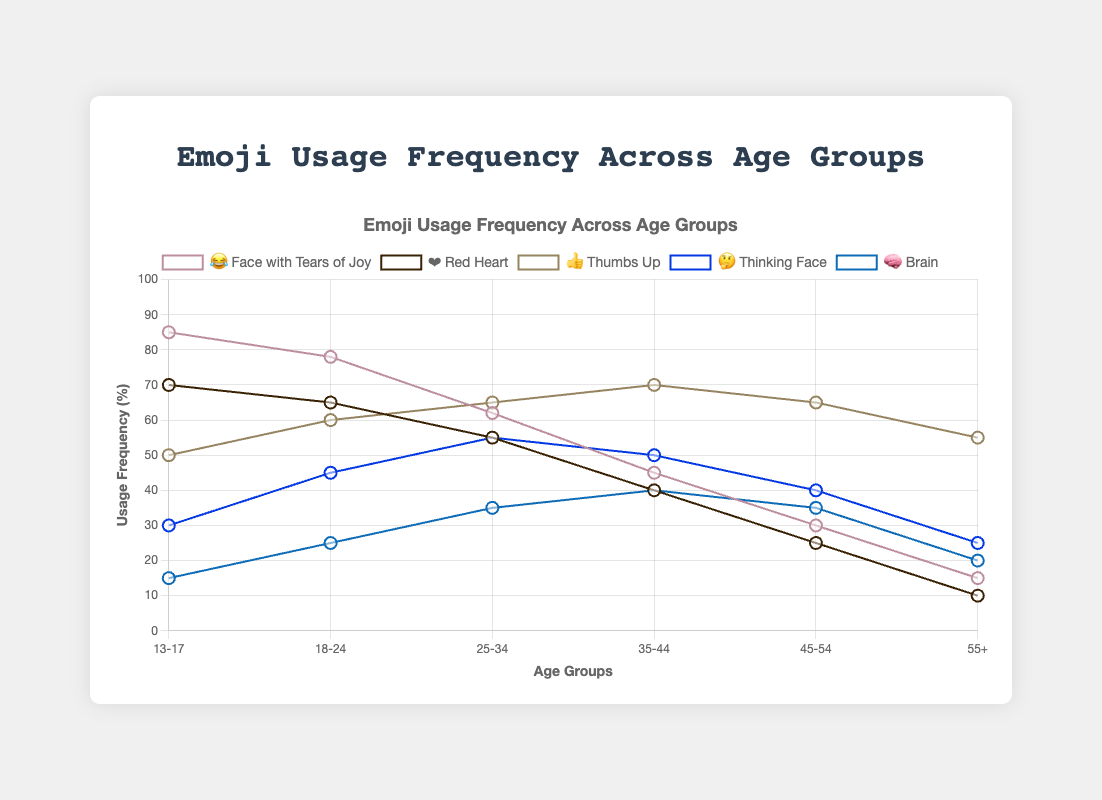Which emoji is used most frequently by the 13-17 age group? The emoji with the highest usage frequency for the 13-17 age group can be seen at the tallest point on the graph for that age group. Among the emojis, 😂 (Face with Tears of Joy) has the highest frequency at 85%.
Answer: 😂 (Face with Tears of Joy) What is the trend of usage frequency for the 'Thumbs Up' emoji (👍) across different age groups? Observing the trend line for the Thumbs Up emoji, its usage frequency shows an increasing pattern from the 13-17 age group to the 35-44 age group, peaking at 70%, and subsequently slightly decreasing to 55% in the 55+ age group.
Answer: Increasing, then slightly decreasing Compare the usage frequency of the 'Red Heart' emoji (❤️) between the 18-24 age group and the 55+ age group. The usage frequency for the 'Red Heart' emoji is at 65% for the 18-24 age group. In the 55+ age group, it is at 10%. By comparing these figures, the 18-24 age group uses this emoji significantly more frequently.
Answer: 65% vs. 10% What is the average usage frequency of the 'Brain' emoji (🧠) across all age groups? The usage frequencies for the 'Brain' emoji across the age groups are 15, 25, 35, 40, 35, and 20. Summing these gives 170, and dividing by 6 age groups, the average use is 28.3%.
Answer: 28.3% Which age group shows the lowest usage frequency for the 'Thinking Face' emoji (🤔)? The lowest usage frequency for the 'Thinking Face' emoji can be found by checking all the plotted points for this emoji. The 13-17 age group uses it the least at 30%.
Answer: 13-17 By how much does the usage of the 'Face with Tears of Joy' emoji (😂) decrease from the 13-17 age group to the 35-44 age group? The usage frequency of 'Face with Tears of Joy' emoji decreases from 85% (13-17 age group) to 45% (35-44 age group). The difference is calculated as 85 - 45 = 40%.
Answer: 40% Which emoji is the most consistently used across the different age groups? The emoji with the most consistent usage across age groups is the ones whose trend line shows the least fluctuation. 'Thumbs Up' emoji maintains a relatively stable usage frequency compared to others.
Answer: 👍 (Thumbs Up) In which age group is the 'Brain' emoji (🧠) most frequently used? The 'Brain' emoji is most frequently used in the 35-44 age group, where its usage frequency peaks at 40%.
Answer: 35-44 